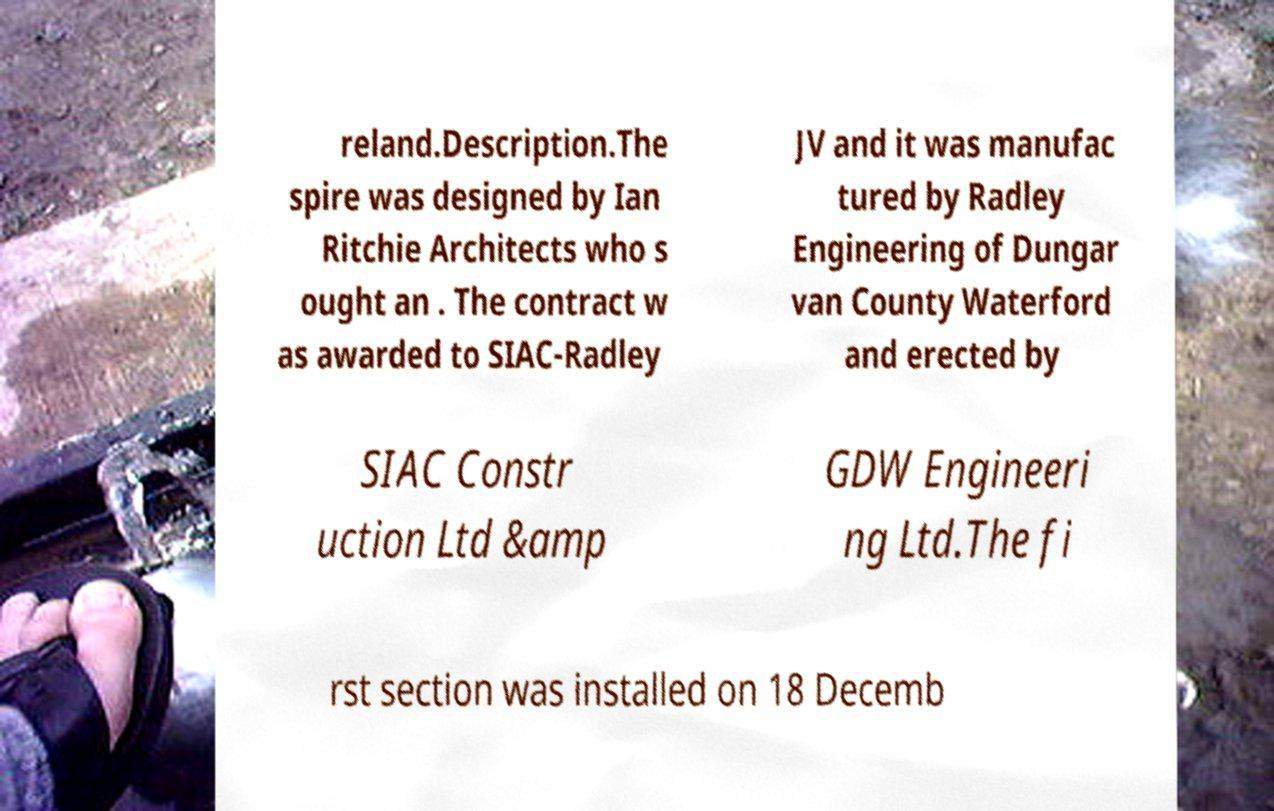What messages or text are displayed in this image? I need them in a readable, typed format. reland.Description.The spire was designed by Ian Ritchie Architects who s ought an . The contract w as awarded to SIAC-Radley JV and it was manufac tured by Radley Engineering of Dungar van County Waterford and erected by SIAC Constr uction Ltd &amp GDW Engineeri ng Ltd.The fi rst section was installed on 18 Decemb 